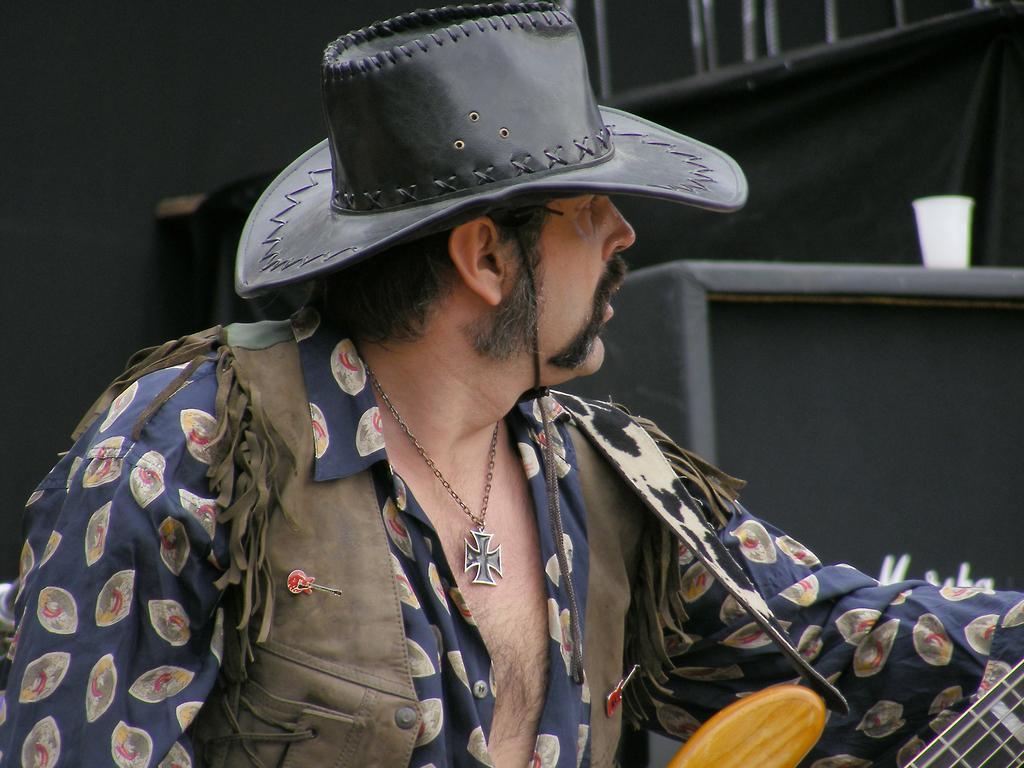Describe this image in one or two sentences. In this image there is a person playing guitar and he is looking to the right side of the image. 